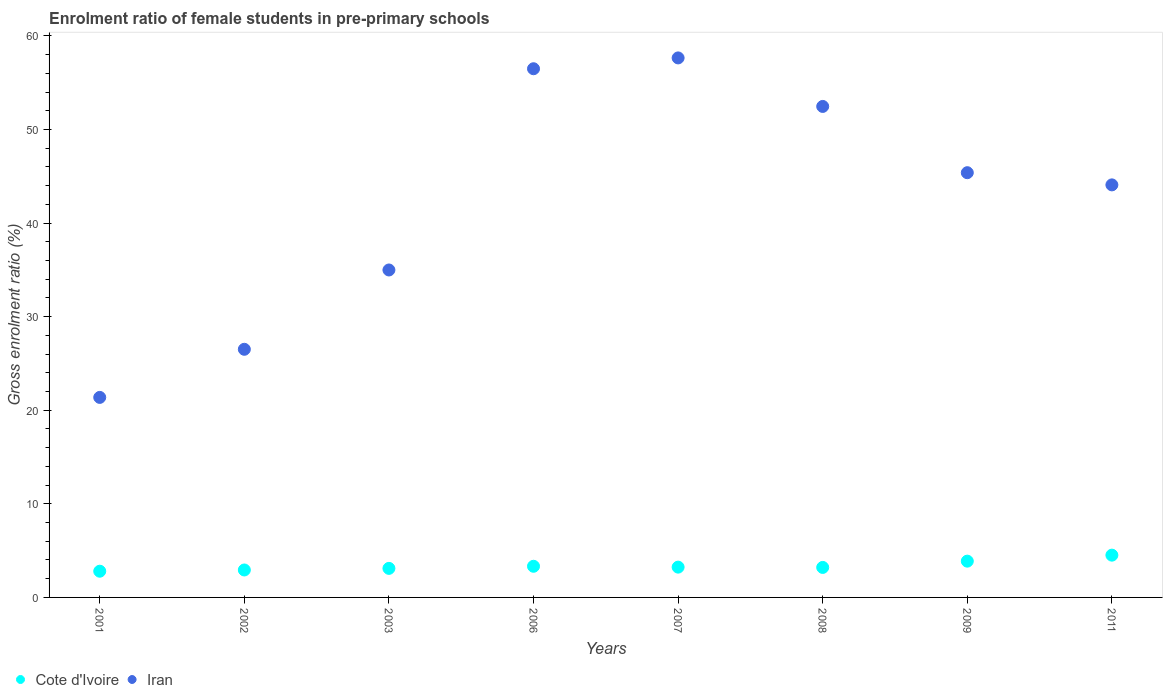Is the number of dotlines equal to the number of legend labels?
Your response must be concise. Yes. What is the enrolment ratio of female students in pre-primary schools in Iran in 2001?
Keep it short and to the point. 21.37. Across all years, what is the maximum enrolment ratio of female students in pre-primary schools in Cote d'Ivoire?
Keep it short and to the point. 4.52. Across all years, what is the minimum enrolment ratio of female students in pre-primary schools in Cote d'Ivoire?
Keep it short and to the point. 2.8. In which year was the enrolment ratio of female students in pre-primary schools in Cote d'Ivoire minimum?
Keep it short and to the point. 2001. What is the total enrolment ratio of female students in pre-primary schools in Cote d'Ivoire in the graph?
Offer a very short reply. 27. What is the difference between the enrolment ratio of female students in pre-primary schools in Cote d'Ivoire in 2001 and that in 2008?
Your answer should be very brief. -0.4. What is the difference between the enrolment ratio of female students in pre-primary schools in Cote d'Ivoire in 2001 and the enrolment ratio of female students in pre-primary schools in Iran in 2007?
Your answer should be very brief. -54.85. What is the average enrolment ratio of female students in pre-primary schools in Cote d'Ivoire per year?
Offer a very short reply. 3.38. In the year 2011, what is the difference between the enrolment ratio of female students in pre-primary schools in Iran and enrolment ratio of female students in pre-primary schools in Cote d'Ivoire?
Provide a short and direct response. 39.57. What is the ratio of the enrolment ratio of female students in pre-primary schools in Iran in 2008 to that in 2009?
Offer a terse response. 1.16. Is the enrolment ratio of female students in pre-primary schools in Cote d'Ivoire in 2006 less than that in 2011?
Your answer should be compact. Yes. What is the difference between the highest and the second highest enrolment ratio of female students in pre-primary schools in Cote d'Ivoire?
Keep it short and to the point. 0.64. What is the difference between the highest and the lowest enrolment ratio of female students in pre-primary schools in Cote d'Ivoire?
Your answer should be very brief. 1.72. In how many years, is the enrolment ratio of female students in pre-primary schools in Cote d'Ivoire greater than the average enrolment ratio of female students in pre-primary schools in Cote d'Ivoire taken over all years?
Give a very brief answer. 2. Is the sum of the enrolment ratio of female students in pre-primary schools in Cote d'Ivoire in 2001 and 2002 greater than the maximum enrolment ratio of female students in pre-primary schools in Iran across all years?
Your response must be concise. No. Does the enrolment ratio of female students in pre-primary schools in Cote d'Ivoire monotonically increase over the years?
Make the answer very short. No. What is the difference between two consecutive major ticks on the Y-axis?
Provide a short and direct response. 10. Does the graph contain any zero values?
Your answer should be very brief. No. Does the graph contain grids?
Your answer should be compact. No. Where does the legend appear in the graph?
Ensure brevity in your answer.  Bottom left. How are the legend labels stacked?
Give a very brief answer. Horizontal. What is the title of the graph?
Your response must be concise. Enrolment ratio of female students in pre-primary schools. What is the Gross enrolment ratio (%) in Cote d'Ivoire in 2001?
Your response must be concise. 2.8. What is the Gross enrolment ratio (%) of Iran in 2001?
Your response must be concise. 21.37. What is the Gross enrolment ratio (%) in Cote d'Ivoire in 2002?
Provide a succinct answer. 2.93. What is the Gross enrolment ratio (%) in Iran in 2002?
Give a very brief answer. 26.51. What is the Gross enrolment ratio (%) of Cote d'Ivoire in 2003?
Make the answer very short. 3.1. What is the Gross enrolment ratio (%) of Iran in 2003?
Provide a short and direct response. 34.99. What is the Gross enrolment ratio (%) in Cote d'Ivoire in 2006?
Give a very brief answer. 3.33. What is the Gross enrolment ratio (%) of Iran in 2006?
Keep it short and to the point. 56.49. What is the Gross enrolment ratio (%) in Cote d'Ivoire in 2007?
Your answer should be very brief. 3.24. What is the Gross enrolment ratio (%) of Iran in 2007?
Provide a short and direct response. 57.65. What is the Gross enrolment ratio (%) in Cote d'Ivoire in 2008?
Keep it short and to the point. 3.21. What is the Gross enrolment ratio (%) of Iran in 2008?
Give a very brief answer. 52.46. What is the Gross enrolment ratio (%) in Cote d'Ivoire in 2009?
Your response must be concise. 3.88. What is the Gross enrolment ratio (%) in Iran in 2009?
Make the answer very short. 45.38. What is the Gross enrolment ratio (%) of Cote d'Ivoire in 2011?
Make the answer very short. 4.52. What is the Gross enrolment ratio (%) of Iran in 2011?
Keep it short and to the point. 44.08. Across all years, what is the maximum Gross enrolment ratio (%) of Cote d'Ivoire?
Offer a very short reply. 4.52. Across all years, what is the maximum Gross enrolment ratio (%) in Iran?
Ensure brevity in your answer.  57.65. Across all years, what is the minimum Gross enrolment ratio (%) of Cote d'Ivoire?
Your answer should be compact. 2.8. Across all years, what is the minimum Gross enrolment ratio (%) in Iran?
Offer a terse response. 21.37. What is the total Gross enrolment ratio (%) in Cote d'Ivoire in the graph?
Your response must be concise. 27. What is the total Gross enrolment ratio (%) in Iran in the graph?
Provide a succinct answer. 338.95. What is the difference between the Gross enrolment ratio (%) in Cote d'Ivoire in 2001 and that in 2002?
Give a very brief answer. -0.13. What is the difference between the Gross enrolment ratio (%) of Iran in 2001 and that in 2002?
Keep it short and to the point. -5.14. What is the difference between the Gross enrolment ratio (%) of Cote d'Ivoire in 2001 and that in 2003?
Make the answer very short. -0.3. What is the difference between the Gross enrolment ratio (%) of Iran in 2001 and that in 2003?
Make the answer very short. -13.62. What is the difference between the Gross enrolment ratio (%) in Cote d'Ivoire in 2001 and that in 2006?
Provide a short and direct response. -0.53. What is the difference between the Gross enrolment ratio (%) of Iran in 2001 and that in 2006?
Offer a very short reply. -35.12. What is the difference between the Gross enrolment ratio (%) of Cote d'Ivoire in 2001 and that in 2007?
Your answer should be very brief. -0.44. What is the difference between the Gross enrolment ratio (%) in Iran in 2001 and that in 2007?
Make the answer very short. -36.28. What is the difference between the Gross enrolment ratio (%) of Cote d'Ivoire in 2001 and that in 2008?
Provide a succinct answer. -0.4. What is the difference between the Gross enrolment ratio (%) in Iran in 2001 and that in 2008?
Keep it short and to the point. -31.09. What is the difference between the Gross enrolment ratio (%) of Cote d'Ivoire in 2001 and that in 2009?
Your answer should be very brief. -1.08. What is the difference between the Gross enrolment ratio (%) of Iran in 2001 and that in 2009?
Offer a very short reply. -24.01. What is the difference between the Gross enrolment ratio (%) in Cote d'Ivoire in 2001 and that in 2011?
Offer a terse response. -1.72. What is the difference between the Gross enrolment ratio (%) in Iran in 2001 and that in 2011?
Ensure brevity in your answer.  -22.71. What is the difference between the Gross enrolment ratio (%) in Cote d'Ivoire in 2002 and that in 2003?
Your answer should be very brief. -0.17. What is the difference between the Gross enrolment ratio (%) of Iran in 2002 and that in 2003?
Provide a short and direct response. -8.48. What is the difference between the Gross enrolment ratio (%) of Cote d'Ivoire in 2002 and that in 2006?
Provide a short and direct response. -0.4. What is the difference between the Gross enrolment ratio (%) in Iran in 2002 and that in 2006?
Your response must be concise. -29.98. What is the difference between the Gross enrolment ratio (%) of Cote d'Ivoire in 2002 and that in 2007?
Your response must be concise. -0.3. What is the difference between the Gross enrolment ratio (%) of Iran in 2002 and that in 2007?
Provide a succinct answer. -31.14. What is the difference between the Gross enrolment ratio (%) of Cote d'Ivoire in 2002 and that in 2008?
Provide a short and direct response. -0.27. What is the difference between the Gross enrolment ratio (%) in Iran in 2002 and that in 2008?
Provide a short and direct response. -25.95. What is the difference between the Gross enrolment ratio (%) of Cote d'Ivoire in 2002 and that in 2009?
Provide a succinct answer. -0.94. What is the difference between the Gross enrolment ratio (%) in Iran in 2002 and that in 2009?
Give a very brief answer. -18.87. What is the difference between the Gross enrolment ratio (%) in Cote d'Ivoire in 2002 and that in 2011?
Your answer should be very brief. -1.58. What is the difference between the Gross enrolment ratio (%) in Iran in 2002 and that in 2011?
Provide a succinct answer. -17.57. What is the difference between the Gross enrolment ratio (%) in Cote d'Ivoire in 2003 and that in 2006?
Provide a short and direct response. -0.23. What is the difference between the Gross enrolment ratio (%) of Iran in 2003 and that in 2006?
Make the answer very short. -21.5. What is the difference between the Gross enrolment ratio (%) of Cote d'Ivoire in 2003 and that in 2007?
Offer a terse response. -0.13. What is the difference between the Gross enrolment ratio (%) in Iran in 2003 and that in 2007?
Your answer should be very brief. -22.66. What is the difference between the Gross enrolment ratio (%) in Cote d'Ivoire in 2003 and that in 2008?
Your answer should be compact. -0.1. What is the difference between the Gross enrolment ratio (%) in Iran in 2003 and that in 2008?
Make the answer very short. -17.48. What is the difference between the Gross enrolment ratio (%) of Cote d'Ivoire in 2003 and that in 2009?
Make the answer very short. -0.77. What is the difference between the Gross enrolment ratio (%) in Iran in 2003 and that in 2009?
Provide a succinct answer. -10.4. What is the difference between the Gross enrolment ratio (%) in Cote d'Ivoire in 2003 and that in 2011?
Make the answer very short. -1.41. What is the difference between the Gross enrolment ratio (%) in Iran in 2003 and that in 2011?
Offer a very short reply. -9.09. What is the difference between the Gross enrolment ratio (%) in Cote d'Ivoire in 2006 and that in 2007?
Provide a succinct answer. 0.09. What is the difference between the Gross enrolment ratio (%) in Iran in 2006 and that in 2007?
Provide a succinct answer. -1.16. What is the difference between the Gross enrolment ratio (%) of Cote d'Ivoire in 2006 and that in 2008?
Give a very brief answer. 0.12. What is the difference between the Gross enrolment ratio (%) in Iran in 2006 and that in 2008?
Ensure brevity in your answer.  4.03. What is the difference between the Gross enrolment ratio (%) of Cote d'Ivoire in 2006 and that in 2009?
Keep it short and to the point. -0.55. What is the difference between the Gross enrolment ratio (%) of Iran in 2006 and that in 2009?
Give a very brief answer. 11.11. What is the difference between the Gross enrolment ratio (%) of Cote d'Ivoire in 2006 and that in 2011?
Offer a very short reply. -1.19. What is the difference between the Gross enrolment ratio (%) in Iran in 2006 and that in 2011?
Offer a very short reply. 12.41. What is the difference between the Gross enrolment ratio (%) of Cote d'Ivoire in 2007 and that in 2008?
Your answer should be very brief. 0.03. What is the difference between the Gross enrolment ratio (%) of Iran in 2007 and that in 2008?
Your response must be concise. 5.18. What is the difference between the Gross enrolment ratio (%) of Cote d'Ivoire in 2007 and that in 2009?
Provide a short and direct response. -0.64. What is the difference between the Gross enrolment ratio (%) of Iran in 2007 and that in 2009?
Offer a terse response. 12.27. What is the difference between the Gross enrolment ratio (%) of Cote d'Ivoire in 2007 and that in 2011?
Keep it short and to the point. -1.28. What is the difference between the Gross enrolment ratio (%) in Iran in 2007 and that in 2011?
Keep it short and to the point. 13.57. What is the difference between the Gross enrolment ratio (%) in Cote d'Ivoire in 2008 and that in 2009?
Provide a succinct answer. -0.67. What is the difference between the Gross enrolment ratio (%) in Iran in 2008 and that in 2009?
Your answer should be compact. 7.08. What is the difference between the Gross enrolment ratio (%) in Cote d'Ivoire in 2008 and that in 2011?
Your response must be concise. -1.31. What is the difference between the Gross enrolment ratio (%) in Iran in 2008 and that in 2011?
Offer a very short reply. 8.38. What is the difference between the Gross enrolment ratio (%) in Cote d'Ivoire in 2009 and that in 2011?
Provide a succinct answer. -0.64. What is the difference between the Gross enrolment ratio (%) of Iran in 2009 and that in 2011?
Ensure brevity in your answer.  1.3. What is the difference between the Gross enrolment ratio (%) of Cote d'Ivoire in 2001 and the Gross enrolment ratio (%) of Iran in 2002?
Provide a succinct answer. -23.71. What is the difference between the Gross enrolment ratio (%) of Cote d'Ivoire in 2001 and the Gross enrolment ratio (%) of Iran in 2003?
Give a very brief answer. -32.19. What is the difference between the Gross enrolment ratio (%) in Cote d'Ivoire in 2001 and the Gross enrolment ratio (%) in Iran in 2006?
Ensure brevity in your answer.  -53.69. What is the difference between the Gross enrolment ratio (%) of Cote d'Ivoire in 2001 and the Gross enrolment ratio (%) of Iran in 2007?
Provide a succinct answer. -54.85. What is the difference between the Gross enrolment ratio (%) in Cote d'Ivoire in 2001 and the Gross enrolment ratio (%) in Iran in 2008?
Your response must be concise. -49.66. What is the difference between the Gross enrolment ratio (%) in Cote d'Ivoire in 2001 and the Gross enrolment ratio (%) in Iran in 2009?
Provide a succinct answer. -42.58. What is the difference between the Gross enrolment ratio (%) in Cote d'Ivoire in 2001 and the Gross enrolment ratio (%) in Iran in 2011?
Ensure brevity in your answer.  -41.28. What is the difference between the Gross enrolment ratio (%) in Cote d'Ivoire in 2002 and the Gross enrolment ratio (%) in Iran in 2003?
Make the answer very short. -32.06. What is the difference between the Gross enrolment ratio (%) in Cote d'Ivoire in 2002 and the Gross enrolment ratio (%) in Iran in 2006?
Your response must be concise. -53.56. What is the difference between the Gross enrolment ratio (%) in Cote d'Ivoire in 2002 and the Gross enrolment ratio (%) in Iran in 2007?
Your answer should be very brief. -54.72. What is the difference between the Gross enrolment ratio (%) of Cote d'Ivoire in 2002 and the Gross enrolment ratio (%) of Iran in 2008?
Make the answer very short. -49.53. What is the difference between the Gross enrolment ratio (%) of Cote d'Ivoire in 2002 and the Gross enrolment ratio (%) of Iran in 2009?
Provide a succinct answer. -42.45. What is the difference between the Gross enrolment ratio (%) of Cote d'Ivoire in 2002 and the Gross enrolment ratio (%) of Iran in 2011?
Offer a very short reply. -41.15. What is the difference between the Gross enrolment ratio (%) in Cote d'Ivoire in 2003 and the Gross enrolment ratio (%) in Iran in 2006?
Provide a short and direct response. -53.39. What is the difference between the Gross enrolment ratio (%) of Cote d'Ivoire in 2003 and the Gross enrolment ratio (%) of Iran in 2007?
Keep it short and to the point. -54.55. What is the difference between the Gross enrolment ratio (%) of Cote d'Ivoire in 2003 and the Gross enrolment ratio (%) of Iran in 2008?
Your response must be concise. -49.36. What is the difference between the Gross enrolment ratio (%) in Cote d'Ivoire in 2003 and the Gross enrolment ratio (%) in Iran in 2009?
Ensure brevity in your answer.  -42.28. What is the difference between the Gross enrolment ratio (%) of Cote d'Ivoire in 2003 and the Gross enrolment ratio (%) of Iran in 2011?
Give a very brief answer. -40.98. What is the difference between the Gross enrolment ratio (%) in Cote d'Ivoire in 2006 and the Gross enrolment ratio (%) in Iran in 2007?
Provide a short and direct response. -54.32. What is the difference between the Gross enrolment ratio (%) in Cote d'Ivoire in 2006 and the Gross enrolment ratio (%) in Iran in 2008?
Offer a very short reply. -49.14. What is the difference between the Gross enrolment ratio (%) of Cote d'Ivoire in 2006 and the Gross enrolment ratio (%) of Iran in 2009?
Your answer should be very brief. -42.05. What is the difference between the Gross enrolment ratio (%) in Cote d'Ivoire in 2006 and the Gross enrolment ratio (%) in Iran in 2011?
Make the answer very short. -40.75. What is the difference between the Gross enrolment ratio (%) in Cote d'Ivoire in 2007 and the Gross enrolment ratio (%) in Iran in 2008?
Give a very brief answer. -49.23. What is the difference between the Gross enrolment ratio (%) in Cote d'Ivoire in 2007 and the Gross enrolment ratio (%) in Iran in 2009?
Your answer should be very brief. -42.15. What is the difference between the Gross enrolment ratio (%) in Cote d'Ivoire in 2007 and the Gross enrolment ratio (%) in Iran in 2011?
Provide a succinct answer. -40.85. What is the difference between the Gross enrolment ratio (%) of Cote d'Ivoire in 2008 and the Gross enrolment ratio (%) of Iran in 2009?
Offer a terse response. -42.18. What is the difference between the Gross enrolment ratio (%) of Cote d'Ivoire in 2008 and the Gross enrolment ratio (%) of Iran in 2011?
Your answer should be very brief. -40.88. What is the difference between the Gross enrolment ratio (%) in Cote d'Ivoire in 2009 and the Gross enrolment ratio (%) in Iran in 2011?
Offer a very short reply. -40.21. What is the average Gross enrolment ratio (%) in Cote d'Ivoire per year?
Ensure brevity in your answer.  3.38. What is the average Gross enrolment ratio (%) of Iran per year?
Your response must be concise. 42.37. In the year 2001, what is the difference between the Gross enrolment ratio (%) in Cote d'Ivoire and Gross enrolment ratio (%) in Iran?
Your answer should be compact. -18.57. In the year 2002, what is the difference between the Gross enrolment ratio (%) of Cote d'Ivoire and Gross enrolment ratio (%) of Iran?
Offer a very short reply. -23.58. In the year 2003, what is the difference between the Gross enrolment ratio (%) of Cote d'Ivoire and Gross enrolment ratio (%) of Iran?
Provide a succinct answer. -31.89. In the year 2006, what is the difference between the Gross enrolment ratio (%) of Cote d'Ivoire and Gross enrolment ratio (%) of Iran?
Ensure brevity in your answer.  -53.16. In the year 2007, what is the difference between the Gross enrolment ratio (%) in Cote d'Ivoire and Gross enrolment ratio (%) in Iran?
Your response must be concise. -54.41. In the year 2008, what is the difference between the Gross enrolment ratio (%) in Cote d'Ivoire and Gross enrolment ratio (%) in Iran?
Your answer should be compact. -49.26. In the year 2009, what is the difference between the Gross enrolment ratio (%) of Cote d'Ivoire and Gross enrolment ratio (%) of Iran?
Your answer should be compact. -41.51. In the year 2011, what is the difference between the Gross enrolment ratio (%) in Cote d'Ivoire and Gross enrolment ratio (%) in Iran?
Provide a succinct answer. -39.57. What is the ratio of the Gross enrolment ratio (%) in Cote d'Ivoire in 2001 to that in 2002?
Make the answer very short. 0.95. What is the ratio of the Gross enrolment ratio (%) in Iran in 2001 to that in 2002?
Keep it short and to the point. 0.81. What is the ratio of the Gross enrolment ratio (%) of Cote d'Ivoire in 2001 to that in 2003?
Keep it short and to the point. 0.9. What is the ratio of the Gross enrolment ratio (%) in Iran in 2001 to that in 2003?
Your answer should be compact. 0.61. What is the ratio of the Gross enrolment ratio (%) of Cote d'Ivoire in 2001 to that in 2006?
Offer a terse response. 0.84. What is the ratio of the Gross enrolment ratio (%) of Iran in 2001 to that in 2006?
Ensure brevity in your answer.  0.38. What is the ratio of the Gross enrolment ratio (%) in Cote d'Ivoire in 2001 to that in 2007?
Keep it short and to the point. 0.87. What is the ratio of the Gross enrolment ratio (%) of Iran in 2001 to that in 2007?
Provide a short and direct response. 0.37. What is the ratio of the Gross enrolment ratio (%) in Cote d'Ivoire in 2001 to that in 2008?
Your answer should be very brief. 0.87. What is the ratio of the Gross enrolment ratio (%) of Iran in 2001 to that in 2008?
Give a very brief answer. 0.41. What is the ratio of the Gross enrolment ratio (%) of Cote d'Ivoire in 2001 to that in 2009?
Ensure brevity in your answer.  0.72. What is the ratio of the Gross enrolment ratio (%) in Iran in 2001 to that in 2009?
Your answer should be compact. 0.47. What is the ratio of the Gross enrolment ratio (%) of Cote d'Ivoire in 2001 to that in 2011?
Provide a short and direct response. 0.62. What is the ratio of the Gross enrolment ratio (%) of Iran in 2001 to that in 2011?
Ensure brevity in your answer.  0.48. What is the ratio of the Gross enrolment ratio (%) of Cote d'Ivoire in 2002 to that in 2003?
Offer a very short reply. 0.94. What is the ratio of the Gross enrolment ratio (%) of Iran in 2002 to that in 2003?
Offer a very short reply. 0.76. What is the ratio of the Gross enrolment ratio (%) of Cote d'Ivoire in 2002 to that in 2006?
Offer a terse response. 0.88. What is the ratio of the Gross enrolment ratio (%) in Iran in 2002 to that in 2006?
Your response must be concise. 0.47. What is the ratio of the Gross enrolment ratio (%) in Cote d'Ivoire in 2002 to that in 2007?
Provide a short and direct response. 0.91. What is the ratio of the Gross enrolment ratio (%) in Iran in 2002 to that in 2007?
Your response must be concise. 0.46. What is the ratio of the Gross enrolment ratio (%) of Cote d'Ivoire in 2002 to that in 2008?
Your answer should be compact. 0.92. What is the ratio of the Gross enrolment ratio (%) of Iran in 2002 to that in 2008?
Offer a terse response. 0.51. What is the ratio of the Gross enrolment ratio (%) of Cote d'Ivoire in 2002 to that in 2009?
Make the answer very short. 0.76. What is the ratio of the Gross enrolment ratio (%) of Iran in 2002 to that in 2009?
Ensure brevity in your answer.  0.58. What is the ratio of the Gross enrolment ratio (%) in Cote d'Ivoire in 2002 to that in 2011?
Your response must be concise. 0.65. What is the ratio of the Gross enrolment ratio (%) of Iran in 2002 to that in 2011?
Offer a very short reply. 0.6. What is the ratio of the Gross enrolment ratio (%) in Cote d'Ivoire in 2003 to that in 2006?
Provide a short and direct response. 0.93. What is the ratio of the Gross enrolment ratio (%) of Iran in 2003 to that in 2006?
Offer a very short reply. 0.62. What is the ratio of the Gross enrolment ratio (%) in Cote d'Ivoire in 2003 to that in 2007?
Provide a succinct answer. 0.96. What is the ratio of the Gross enrolment ratio (%) of Iran in 2003 to that in 2007?
Your answer should be compact. 0.61. What is the ratio of the Gross enrolment ratio (%) in Cote d'Ivoire in 2003 to that in 2008?
Make the answer very short. 0.97. What is the ratio of the Gross enrolment ratio (%) of Iran in 2003 to that in 2008?
Provide a succinct answer. 0.67. What is the ratio of the Gross enrolment ratio (%) of Cote d'Ivoire in 2003 to that in 2009?
Keep it short and to the point. 0.8. What is the ratio of the Gross enrolment ratio (%) of Iran in 2003 to that in 2009?
Provide a short and direct response. 0.77. What is the ratio of the Gross enrolment ratio (%) of Cote d'Ivoire in 2003 to that in 2011?
Offer a terse response. 0.69. What is the ratio of the Gross enrolment ratio (%) in Iran in 2003 to that in 2011?
Provide a short and direct response. 0.79. What is the ratio of the Gross enrolment ratio (%) in Cote d'Ivoire in 2006 to that in 2007?
Your response must be concise. 1.03. What is the ratio of the Gross enrolment ratio (%) in Iran in 2006 to that in 2007?
Make the answer very short. 0.98. What is the ratio of the Gross enrolment ratio (%) of Cote d'Ivoire in 2006 to that in 2008?
Provide a short and direct response. 1.04. What is the ratio of the Gross enrolment ratio (%) of Iran in 2006 to that in 2008?
Make the answer very short. 1.08. What is the ratio of the Gross enrolment ratio (%) of Cote d'Ivoire in 2006 to that in 2009?
Keep it short and to the point. 0.86. What is the ratio of the Gross enrolment ratio (%) in Iran in 2006 to that in 2009?
Your answer should be compact. 1.24. What is the ratio of the Gross enrolment ratio (%) in Cote d'Ivoire in 2006 to that in 2011?
Offer a terse response. 0.74. What is the ratio of the Gross enrolment ratio (%) of Iran in 2006 to that in 2011?
Make the answer very short. 1.28. What is the ratio of the Gross enrolment ratio (%) in Cote d'Ivoire in 2007 to that in 2008?
Your answer should be compact. 1.01. What is the ratio of the Gross enrolment ratio (%) of Iran in 2007 to that in 2008?
Provide a succinct answer. 1.1. What is the ratio of the Gross enrolment ratio (%) of Cote d'Ivoire in 2007 to that in 2009?
Give a very brief answer. 0.84. What is the ratio of the Gross enrolment ratio (%) of Iran in 2007 to that in 2009?
Your answer should be very brief. 1.27. What is the ratio of the Gross enrolment ratio (%) in Cote d'Ivoire in 2007 to that in 2011?
Your answer should be very brief. 0.72. What is the ratio of the Gross enrolment ratio (%) in Iran in 2007 to that in 2011?
Provide a short and direct response. 1.31. What is the ratio of the Gross enrolment ratio (%) in Cote d'Ivoire in 2008 to that in 2009?
Make the answer very short. 0.83. What is the ratio of the Gross enrolment ratio (%) of Iran in 2008 to that in 2009?
Your answer should be very brief. 1.16. What is the ratio of the Gross enrolment ratio (%) in Cote d'Ivoire in 2008 to that in 2011?
Provide a succinct answer. 0.71. What is the ratio of the Gross enrolment ratio (%) of Iran in 2008 to that in 2011?
Offer a very short reply. 1.19. What is the ratio of the Gross enrolment ratio (%) in Cote d'Ivoire in 2009 to that in 2011?
Ensure brevity in your answer.  0.86. What is the ratio of the Gross enrolment ratio (%) in Iran in 2009 to that in 2011?
Ensure brevity in your answer.  1.03. What is the difference between the highest and the second highest Gross enrolment ratio (%) of Cote d'Ivoire?
Make the answer very short. 0.64. What is the difference between the highest and the second highest Gross enrolment ratio (%) of Iran?
Offer a terse response. 1.16. What is the difference between the highest and the lowest Gross enrolment ratio (%) of Cote d'Ivoire?
Provide a succinct answer. 1.72. What is the difference between the highest and the lowest Gross enrolment ratio (%) in Iran?
Your answer should be compact. 36.28. 